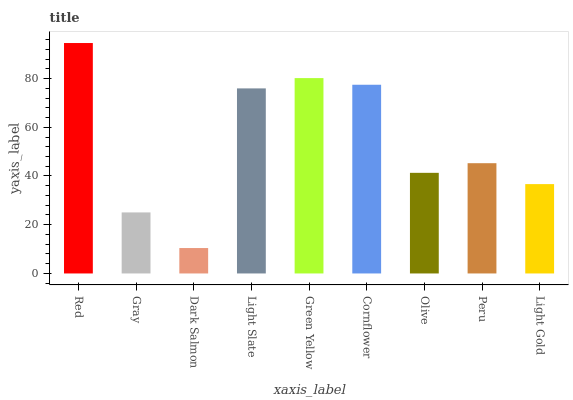Is Dark Salmon the minimum?
Answer yes or no. Yes. Is Red the maximum?
Answer yes or no. Yes. Is Gray the minimum?
Answer yes or no. No. Is Gray the maximum?
Answer yes or no. No. Is Red greater than Gray?
Answer yes or no. Yes. Is Gray less than Red?
Answer yes or no. Yes. Is Gray greater than Red?
Answer yes or no. No. Is Red less than Gray?
Answer yes or no. No. Is Peru the high median?
Answer yes or no. Yes. Is Peru the low median?
Answer yes or no. Yes. Is Light Gold the high median?
Answer yes or no. No. Is Light Gold the low median?
Answer yes or no. No. 